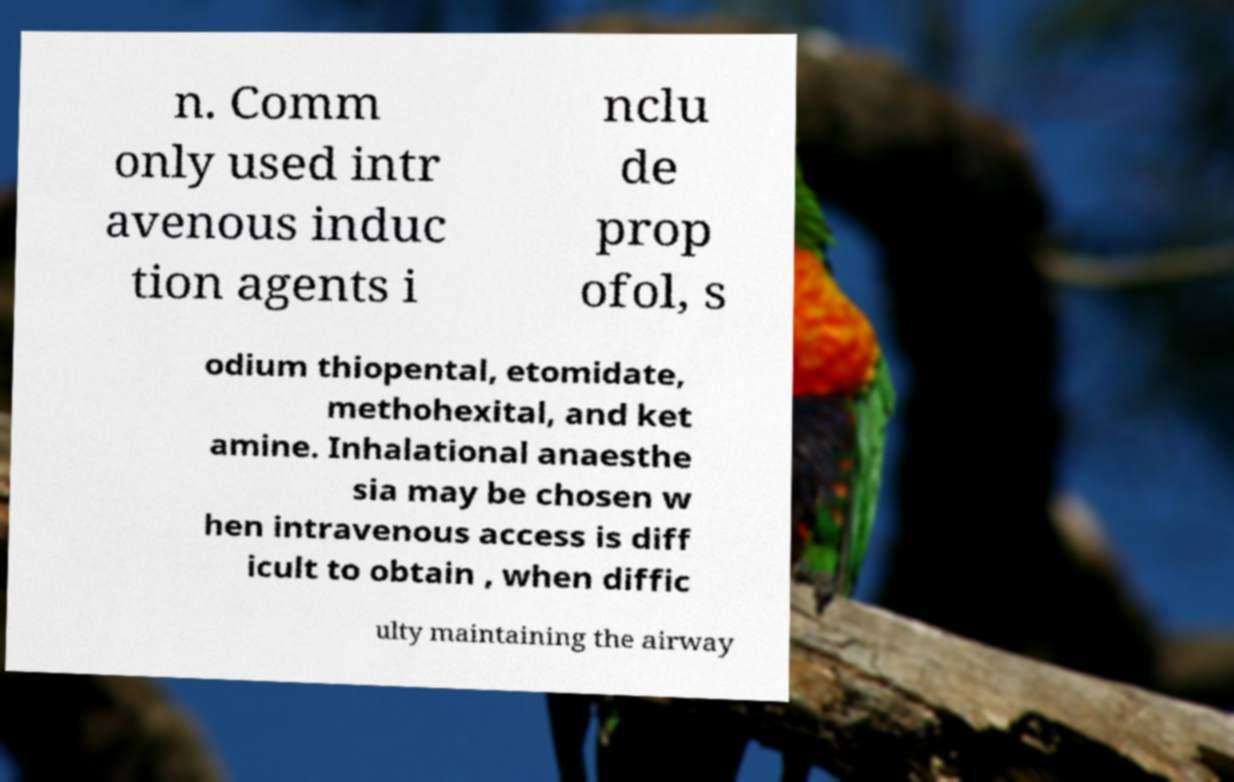Can you read and provide the text displayed in the image?This photo seems to have some interesting text. Can you extract and type it out for me? n. Comm only used intr avenous induc tion agents i nclu de prop ofol, s odium thiopental, etomidate, methohexital, and ket amine. Inhalational anaesthe sia may be chosen w hen intravenous access is diff icult to obtain , when diffic ulty maintaining the airway 